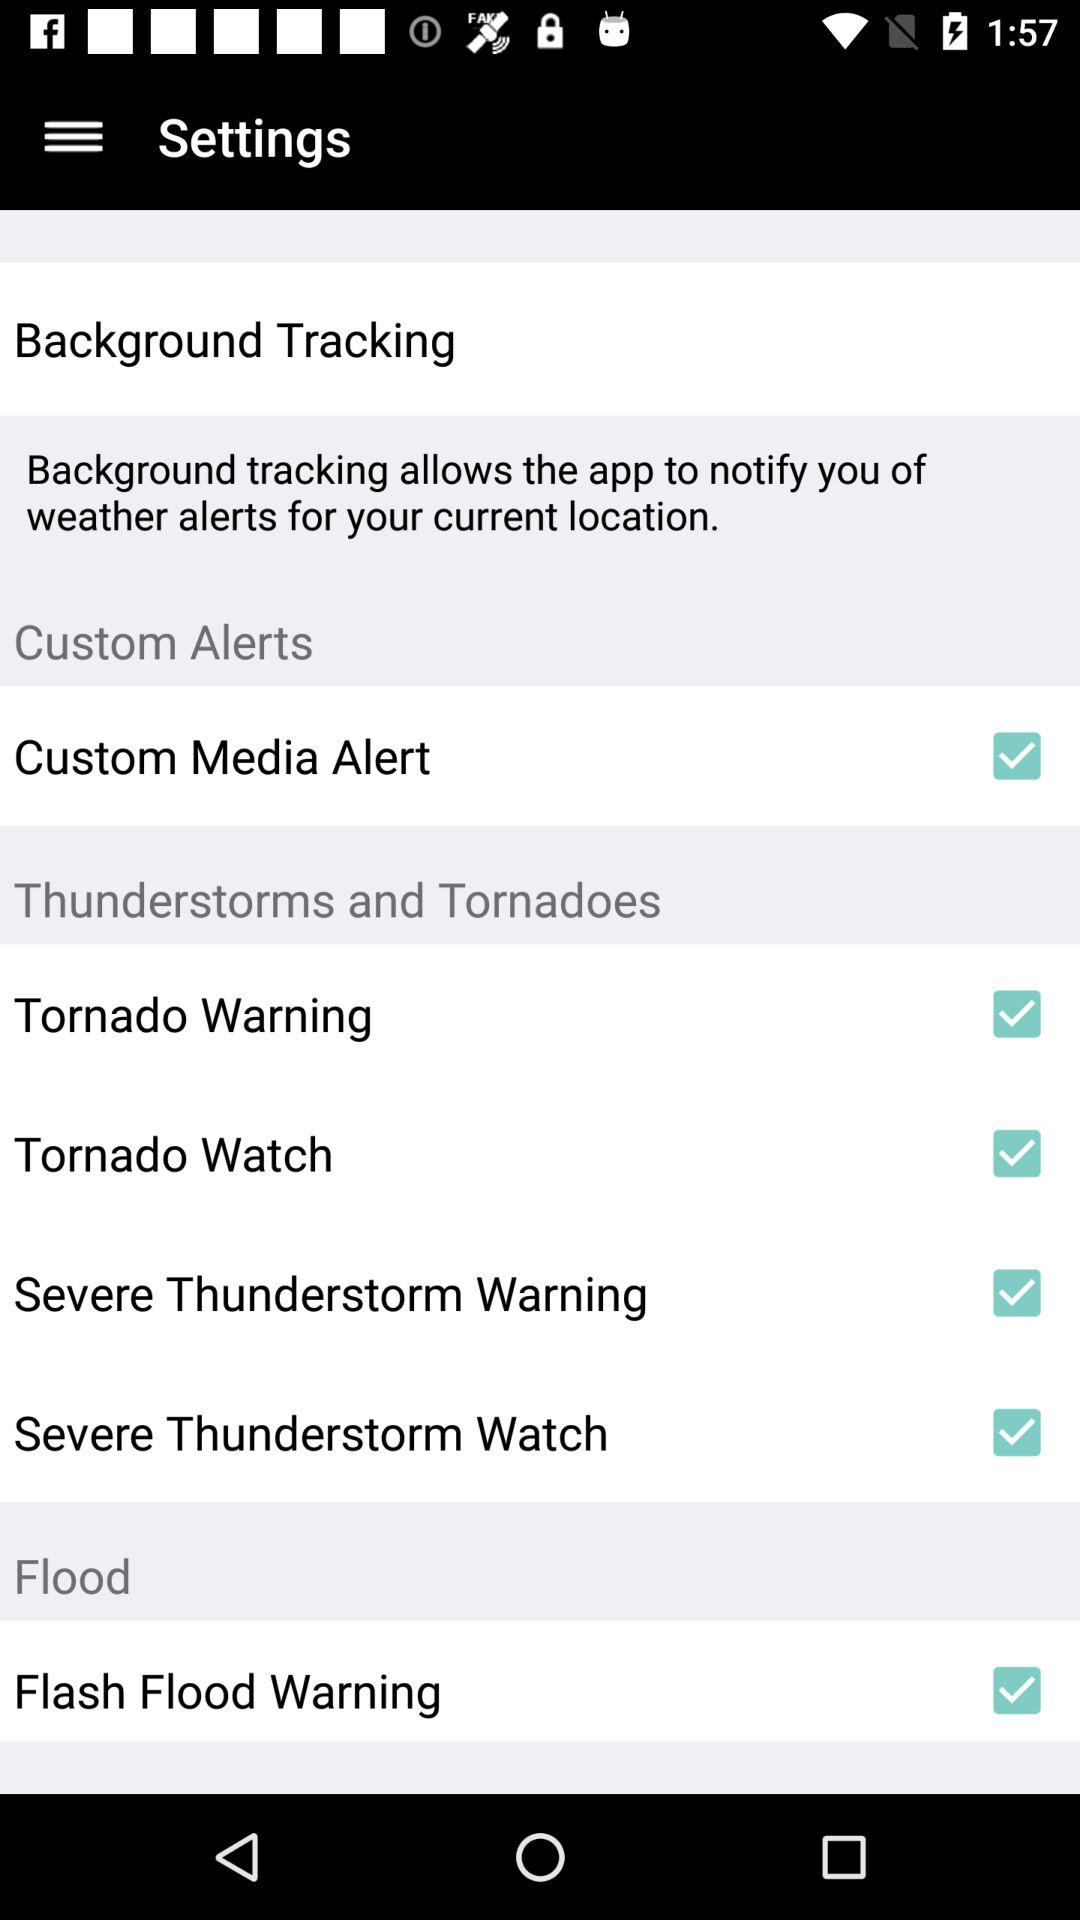What is the current status of "Tornado Watch"? The current status of "Tornado Watch" is "on". 